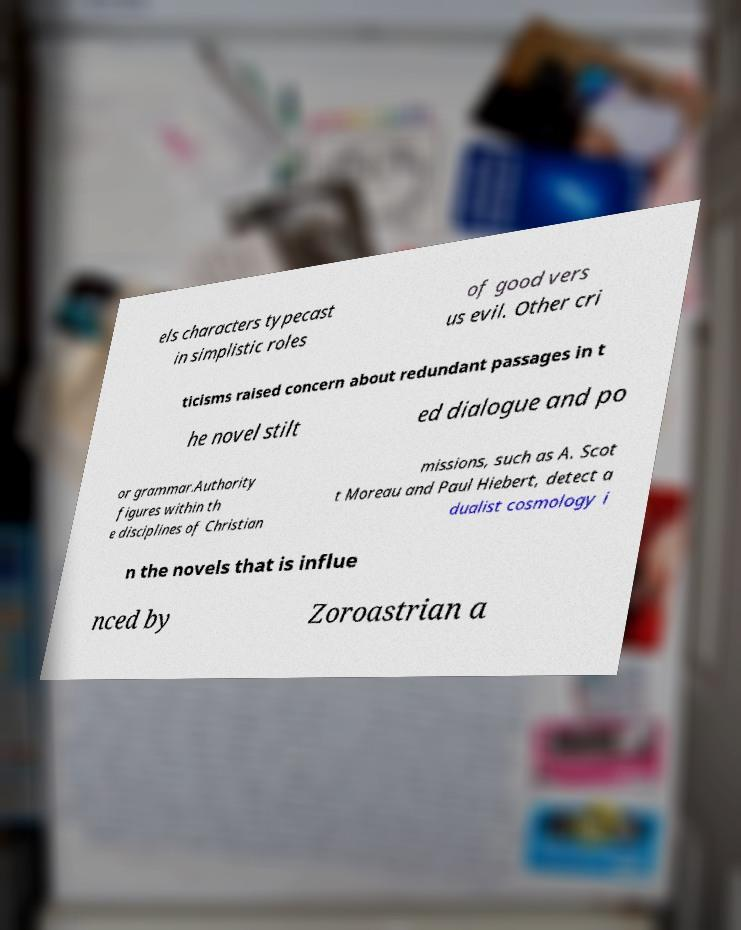What messages or text are displayed in this image? I need them in a readable, typed format. els characters typecast in simplistic roles of good vers us evil. Other cri ticisms raised concern about redundant passages in t he novel stilt ed dialogue and po or grammar.Authority figures within th e disciplines of Christian missions, such as A. Scot t Moreau and Paul Hiebert, detect a dualist cosmology i n the novels that is influe nced by Zoroastrian a 